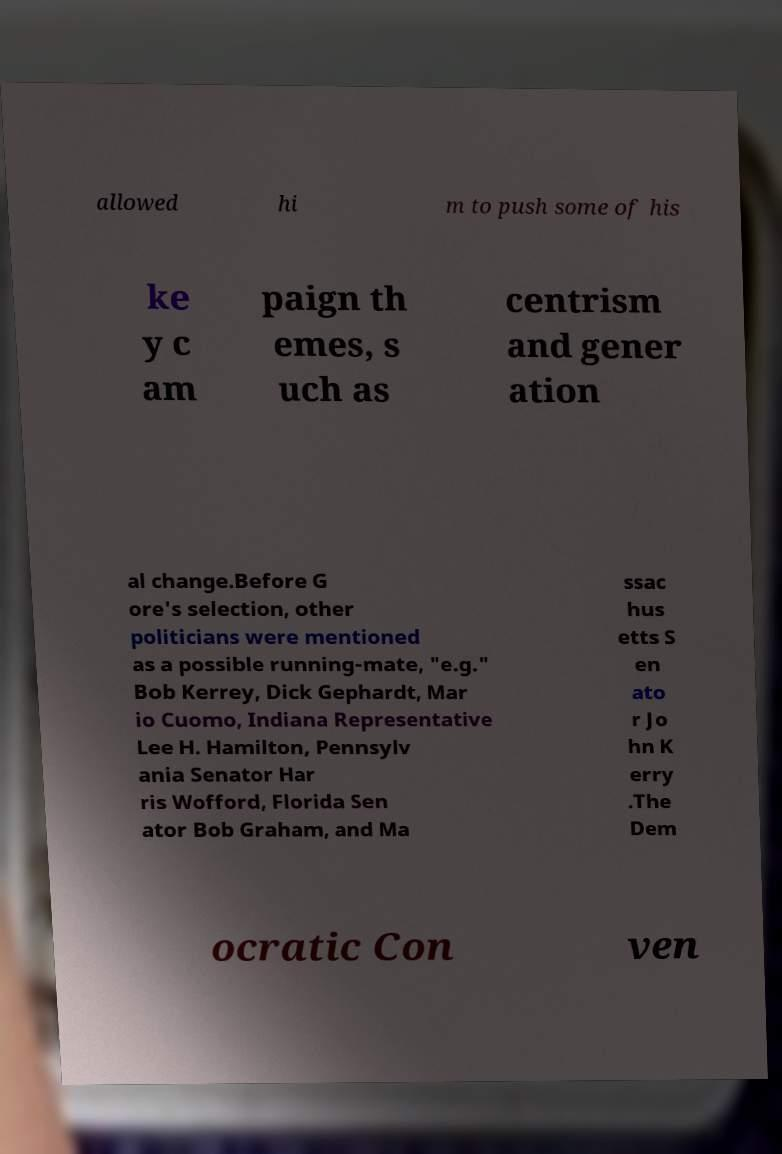Please read and relay the text visible in this image. What does it say? allowed hi m to push some of his ke y c am paign th emes, s uch as centrism and gener ation al change.Before G ore's selection, other politicians were mentioned as a possible running-mate, "e.g." Bob Kerrey, Dick Gephardt, Mar io Cuomo, Indiana Representative Lee H. Hamilton, Pennsylv ania Senator Har ris Wofford, Florida Sen ator Bob Graham, and Ma ssac hus etts S en ato r Jo hn K erry .The Dem ocratic Con ven 